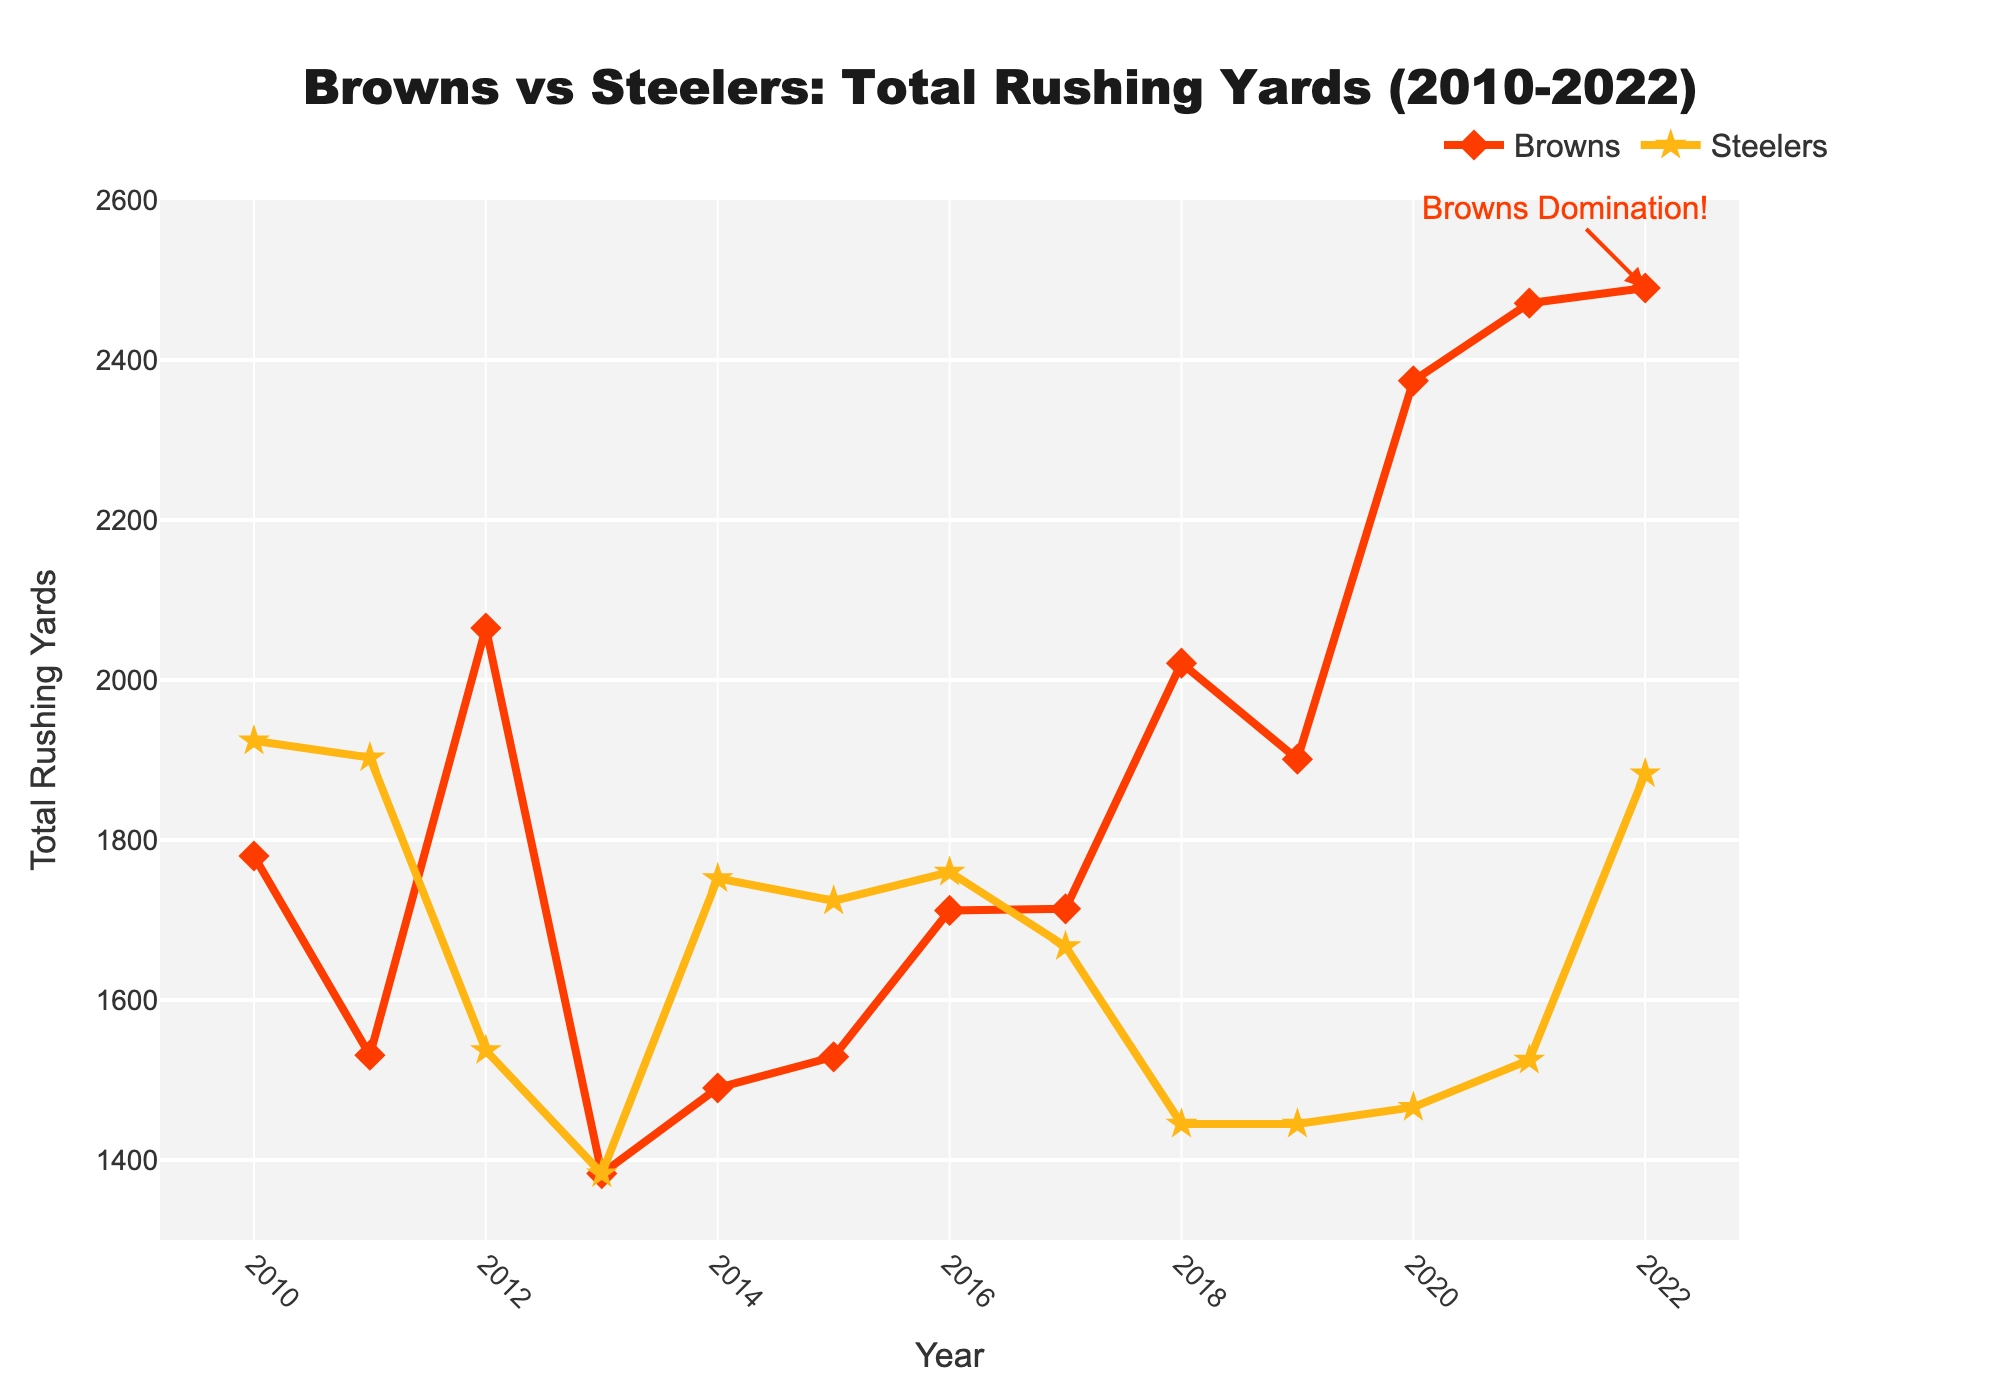Which team had more total rushing yards in 2022? In 2022, the Browns had 2490 rushing yards and the Steelers had 1883 rushing yards. Since 2490 is greater than 1883, the Browns had more total rushing yards.
Answer: Browns What is the range (difference between the highest and lowest values) of the Browns' rushing yards from 2010 to 2022? To find the range, subtract the lowest value from the highest value. The Browns' highest rushing yards in this period was 2490 (in 2022) and the lowest was 1383 (in 2013). So, the range is 2490 - 1383 = 1107.
Answer: 1107 Between which consecutive years did the Steelers see the largest increase in rushing yards? The largest increase can be found by comparing the difference in rushing yards between each consecutive year. The increase between 2021 and 2022 is the largest, as it went from 1525 to 1883, an increase of 358 yards.
Answer: 2021 and 2022 How many times did the Browns have more rushing yards than the Steelers within the 2010-2022 period? By visually inspecting the plots, the Browns had more rushing yards than the Steelers in 2012, 2018, 2019, 2020, 2021, and 2022. That's a total of 6 times.
Answer: 6 In which year did both teams have exactly the same total rushing yards, and what was that value? In 2013, both the Browns and the Steelers had exactly 1383 total rushing yards.
Answer: 2013, 1383 For the Steelers, what is the average total rushing yards from 2010 to 2013? First, sum the total rushing yards for the Steelers from 2010 (1924), 2011 (1903), 2012 (1537), and 2013 (1383). The sum is 1924 + 1903 + 1537 + 1383 = 6747. Then, divide by the number of years (4). So, the average is 6747 / 4 = 1686.75.
Answer: 1686.75 In which year did the Browns surpass 2000 total rushing yards for the first time within the 2010-2022 period? The Browns first surpassed 2000 total rushing yards in 2012 with 2065 rushing yards.
Answer: 2012 Compare the rushing yards trend for the Browns from 2010 to 2013. Did it overall increase, decrease, or remain stable? From 2010 to 2013, the Browns' rushing yards decreased: 1780 (2010) to 1531 (2011) to 2065 (2012) to 1383 (2013). The overall trend shows a decrease.
Answer: Decrease Which year shows the peak performance for the Browns in total rushing yards within the given period? By looking at the data, 2022 is the peak performance year for the Browns with 2490 total rushing yards.
Answer: 2022 